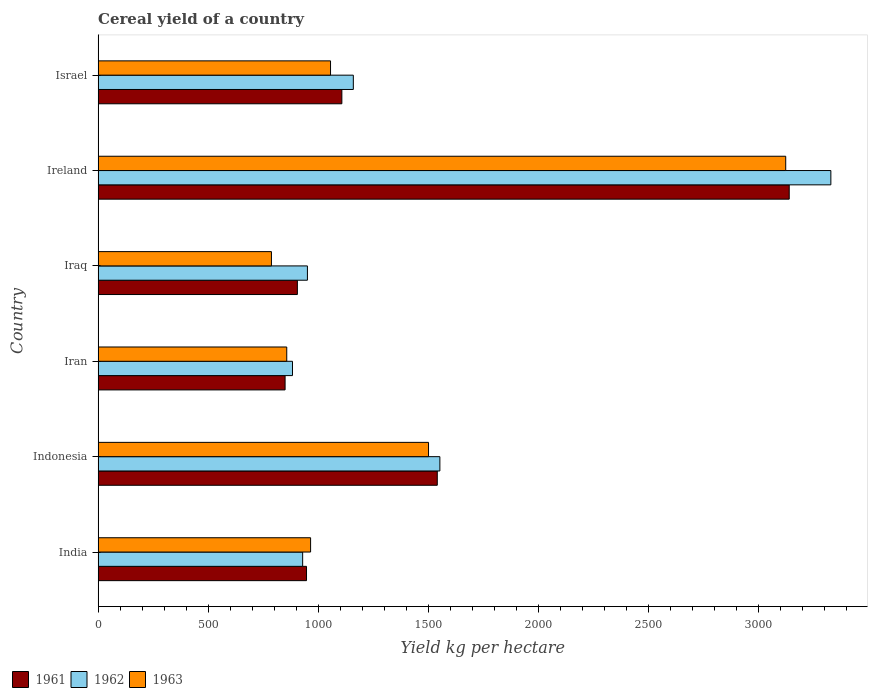How many different coloured bars are there?
Offer a terse response. 3. Are the number of bars on each tick of the Y-axis equal?
Your answer should be very brief. Yes. How many bars are there on the 3rd tick from the top?
Make the answer very short. 3. How many bars are there on the 5th tick from the bottom?
Your response must be concise. 3. What is the total cereal yield in 1963 in Israel?
Provide a succinct answer. 1056.48. Across all countries, what is the maximum total cereal yield in 1961?
Offer a terse response. 3141.5. Across all countries, what is the minimum total cereal yield in 1961?
Your answer should be very brief. 849.91. In which country was the total cereal yield in 1962 maximum?
Make the answer very short. Ireland. In which country was the total cereal yield in 1963 minimum?
Offer a terse response. Iraq. What is the total total cereal yield in 1963 in the graph?
Ensure brevity in your answer.  8295.08. What is the difference between the total cereal yield in 1962 in India and that in Iraq?
Provide a short and direct response. -21.69. What is the difference between the total cereal yield in 1962 in Israel and the total cereal yield in 1961 in Iraq?
Provide a short and direct response. 254.32. What is the average total cereal yield in 1962 per country?
Provide a short and direct response. 1468.19. What is the difference between the total cereal yield in 1963 and total cereal yield in 1961 in Iran?
Offer a terse response. 7.53. In how many countries, is the total cereal yield in 1963 greater than 1500 kg per hectare?
Your answer should be compact. 2. What is the ratio of the total cereal yield in 1962 in Indonesia to that in Ireland?
Your response must be concise. 0.47. Is the difference between the total cereal yield in 1963 in Indonesia and Iran greater than the difference between the total cereal yield in 1961 in Indonesia and Iran?
Give a very brief answer. No. What is the difference between the highest and the second highest total cereal yield in 1961?
Give a very brief answer. 1599.8. What is the difference between the highest and the lowest total cereal yield in 1963?
Your answer should be compact. 2337.75. In how many countries, is the total cereal yield in 1962 greater than the average total cereal yield in 1962 taken over all countries?
Offer a terse response. 2. What does the 3rd bar from the top in Ireland represents?
Your response must be concise. 1961. Is it the case that in every country, the sum of the total cereal yield in 1963 and total cereal yield in 1962 is greater than the total cereal yield in 1961?
Provide a short and direct response. Yes. How many bars are there?
Provide a short and direct response. 18. How many countries are there in the graph?
Make the answer very short. 6. Does the graph contain any zero values?
Make the answer very short. No. What is the title of the graph?
Give a very brief answer. Cereal yield of a country. What is the label or title of the X-axis?
Provide a short and direct response. Yield kg per hectare. What is the label or title of the Y-axis?
Your answer should be very brief. Country. What is the Yield kg per hectare of 1961 in India?
Offer a very short reply. 947.28. What is the Yield kg per hectare of 1962 in India?
Your answer should be very brief. 929.74. What is the Yield kg per hectare in 1963 in India?
Your answer should be compact. 965.82. What is the Yield kg per hectare in 1961 in Indonesia?
Your answer should be compact. 1541.7. What is the Yield kg per hectare in 1962 in Indonesia?
Ensure brevity in your answer.  1553.54. What is the Yield kg per hectare in 1963 in Indonesia?
Provide a succinct answer. 1501.92. What is the Yield kg per hectare in 1961 in Iran?
Keep it short and to the point. 849.91. What is the Yield kg per hectare in 1962 in Iran?
Your answer should be very brief. 883.55. What is the Yield kg per hectare in 1963 in Iran?
Make the answer very short. 857.44. What is the Yield kg per hectare in 1961 in Iraq?
Ensure brevity in your answer.  905.79. What is the Yield kg per hectare of 1962 in Iraq?
Provide a succinct answer. 951.42. What is the Yield kg per hectare in 1963 in Iraq?
Offer a terse response. 787.83. What is the Yield kg per hectare of 1961 in Ireland?
Provide a short and direct response. 3141.5. What is the Yield kg per hectare in 1962 in Ireland?
Offer a terse response. 3330.77. What is the Yield kg per hectare of 1963 in Ireland?
Your answer should be compact. 3125.58. What is the Yield kg per hectare of 1961 in Israel?
Ensure brevity in your answer.  1107.99. What is the Yield kg per hectare of 1962 in Israel?
Offer a very short reply. 1160.11. What is the Yield kg per hectare of 1963 in Israel?
Your answer should be compact. 1056.48. Across all countries, what is the maximum Yield kg per hectare of 1961?
Offer a very short reply. 3141.5. Across all countries, what is the maximum Yield kg per hectare of 1962?
Provide a short and direct response. 3330.77. Across all countries, what is the maximum Yield kg per hectare of 1963?
Make the answer very short. 3125.58. Across all countries, what is the minimum Yield kg per hectare in 1961?
Keep it short and to the point. 849.91. Across all countries, what is the minimum Yield kg per hectare of 1962?
Offer a terse response. 883.55. Across all countries, what is the minimum Yield kg per hectare in 1963?
Your answer should be very brief. 787.83. What is the total Yield kg per hectare in 1961 in the graph?
Your answer should be very brief. 8494.17. What is the total Yield kg per hectare in 1962 in the graph?
Your response must be concise. 8809.13. What is the total Yield kg per hectare in 1963 in the graph?
Your answer should be very brief. 8295.08. What is the difference between the Yield kg per hectare in 1961 in India and that in Indonesia?
Offer a terse response. -594.42. What is the difference between the Yield kg per hectare in 1962 in India and that in Indonesia?
Ensure brevity in your answer.  -623.8. What is the difference between the Yield kg per hectare of 1963 in India and that in Indonesia?
Make the answer very short. -536.09. What is the difference between the Yield kg per hectare of 1961 in India and that in Iran?
Make the answer very short. 97.37. What is the difference between the Yield kg per hectare in 1962 in India and that in Iran?
Your answer should be very brief. 46.18. What is the difference between the Yield kg per hectare of 1963 in India and that in Iran?
Make the answer very short. 108.38. What is the difference between the Yield kg per hectare in 1961 in India and that in Iraq?
Ensure brevity in your answer.  41.5. What is the difference between the Yield kg per hectare in 1962 in India and that in Iraq?
Your response must be concise. -21.69. What is the difference between the Yield kg per hectare in 1963 in India and that in Iraq?
Provide a short and direct response. 177.99. What is the difference between the Yield kg per hectare in 1961 in India and that in Ireland?
Provide a short and direct response. -2194.22. What is the difference between the Yield kg per hectare of 1962 in India and that in Ireland?
Make the answer very short. -2401.03. What is the difference between the Yield kg per hectare in 1963 in India and that in Ireland?
Ensure brevity in your answer.  -2159.76. What is the difference between the Yield kg per hectare in 1961 in India and that in Israel?
Provide a short and direct response. -160.71. What is the difference between the Yield kg per hectare of 1962 in India and that in Israel?
Give a very brief answer. -230.37. What is the difference between the Yield kg per hectare of 1963 in India and that in Israel?
Offer a terse response. -90.66. What is the difference between the Yield kg per hectare in 1961 in Indonesia and that in Iran?
Give a very brief answer. 691.78. What is the difference between the Yield kg per hectare of 1962 in Indonesia and that in Iran?
Ensure brevity in your answer.  669.99. What is the difference between the Yield kg per hectare of 1963 in Indonesia and that in Iran?
Your response must be concise. 644.48. What is the difference between the Yield kg per hectare of 1961 in Indonesia and that in Iraq?
Provide a succinct answer. 635.91. What is the difference between the Yield kg per hectare in 1962 in Indonesia and that in Iraq?
Offer a terse response. 602.11. What is the difference between the Yield kg per hectare of 1963 in Indonesia and that in Iraq?
Offer a terse response. 714.09. What is the difference between the Yield kg per hectare in 1961 in Indonesia and that in Ireland?
Your answer should be very brief. -1599.8. What is the difference between the Yield kg per hectare of 1962 in Indonesia and that in Ireland?
Your response must be concise. -1777.23. What is the difference between the Yield kg per hectare of 1963 in Indonesia and that in Ireland?
Provide a succinct answer. -1623.67. What is the difference between the Yield kg per hectare in 1961 in Indonesia and that in Israel?
Ensure brevity in your answer.  433.71. What is the difference between the Yield kg per hectare of 1962 in Indonesia and that in Israel?
Ensure brevity in your answer.  393.43. What is the difference between the Yield kg per hectare of 1963 in Indonesia and that in Israel?
Provide a short and direct response. 445.43. What is the difference between the Yield kg per hectare of 1961 in Iran and that in Iraq?
Your answer should be compact. -55.87. What is the difference between the Yield kg per hectare of 1962 in Iran and that in Iraq?
Give a very brief answer. -67.87. What is the difference between the Yield kg per hectare of 1963 in Iran and that in Iraq?
Your answer should be compact. 69.61. What is the difference between the Yield kg per hectare of 1961 in Iran and that in Ireland?
Keep it short and to the point. -2291.59. What is the difference between the Yield kg per hectare of 1962 in Iran and that in Ireland?
Provide a short and direct response. -2447.22. What is the difference between the Yield kg per hectare of 1963 in Iran and that in Ireland?
Provide a short and direct response. -2268.14. What is the difference between the Yield kg per hectare of 1961 in Iran and that in Israel?
Ensure brevity in your answer.  -258.07. What is the difference between the Yield kg per hectare of 1962 in Iran and that in Israel?
Provide a short and direct response. -276.55. What is the difference between the Yield kg per hectare in 1963 in Iran and that in Israel?
Your answer should be very brief. -199.04. What is the difference between the Yield kg per hectare of 1961 in Iraq and that in Ireland?
Ensure brevity in your answer.  -2235.71. What is the difference between the Yield kg per hectare in 1962 in Iraq and that in Ireland?
Your answer should be very brief. -2379.35. What is the difference between the Yield kg per hectare in 1963 in Iraq and that in Ireland?
Give a very brief answer. -2337.75. What is the difference between the Yield kg per hectare of 1961 in Iraq and that in Israel?
Your answer should be very brief. -202.2. What is the difference between the Yield kg per hectare of 1962 in Iraq and that in Israel?
Provide a succinct answer. -208.68. What is the difference between the Yield kg per hectare of 1963 in Iraq and that in Israel?
Keep it short and to the point. -268.65. What is the difference between the Yield kg per hectare in 1961 in Ireland and that in Israel?
Provide a short and direct response. 2033.51. What is the difference between the Yield kg per hectare of 1962 in Ireland and that in Israel?
Give a very brief answer. 2170.67. What is the difference between the Yield kg per hectare of 1963 in Ireland and that in Israel?
Give a very brief answer. 2069.1. What is the difference between the Yield kg per hectare of 1961 in India and the Yield kg per hectare of 1962 in Indonesia?
Offer a terse response. -606.25. What is the difference between the Yield kg per hectare in 1961 in India and the Yield kg per hectare in 1963 in Indonesia?
Your answer should be very brief. -554.63. What is the difference between the Yield kg per hectare of 1962 in India and the Yield kg per hectare of 1963 in Indonesia?
Provide a succinct answer. -572.18. What is the difference between the Yield kg per hectare in 1961 in India and the Yield kg per hectare in 1962 in Iran?
Your response must be concise. 63.73. What is the difference between the Yield kg per hectare in 1961 in India and the Yield kg per hectare in 1963 in Iran?
Your answer should be very brief. 89.84. What is the difference between the Yield kg per hectare in 1962 in India and the Yield kg per hectare in 1963 in Iran?
Offer a terse response. 72.3. What is the difference between the Yield kg per hectare in 1961 in India and the Yield kg per hectare in 1962 in Iraq?
Your answer should be very brief. -4.14. What is the difference between the Yield kg per hectare of 1961 in India and the Yield kg per hectare of 1963 in Iraq?
Offer a terse response. 159.45. What is the difference between the Yield kg per hectare of 1962 in India and the Yield kg per hectare of 1963 in Iraq?
Provide a succinct answer. 141.91. What is the difference between the Yield kg per hectare in 1961 in India and the Yield kg per hectare in 1962 in Ireland?
Offer a very short reply. -2383.49. What is the difference between the Yield kg per hectare of 1961 in India and the Yield kg per hectare of 1963 in Ireland?
Provide a short and direct response. -2178.3. What is the difference between the Yield kg per hectare of 1962 in India and the Yield kg per hectare of 1963 in Ireland?
Your answer should be compact. -2195.85. What is the difference between the Yield kg per hectare in 1961 in India and the Yield kg per hectare in 1962 in Israel?
Offer a terse response. -212.82. What is the difference between the Yield kg per hectare of 1961 in India and the Yield kg per hectare of 1963 in Israel?
Your answer should be compact. -109.2. What is the difference between the Yield kg per hectare in 1962 in India and the Yield kg per hectare in 1963 in Israel?
Provide a succinct answer. -126.75. What is the difference between the Yield kg per hectare of 1961 in Indonesia and the Yield kg per hectare of 1962 in Iran?
Ensure brevity in your answer.  658.15. What is the difference between the Yield kg per hectare of 1961 in Indonesia and the Yield kg per hectare of 1963 in Iran?
Offer a very short reply. 684.26. What is the difference between the Yield kg per hectare of 1962 in Indonesia and the Yield kg per hectare of 1963 in Iran?
Give a very brief answer. 696.1. What is the difference between the Yield kg per hectare of 1961 in Indonesia and the Yield kg per hectare of 1962 in Iraq?
Make the answer very short. 590.27. What is the difference between the Yield kg per hectare in 1961 in Indonesia and the Yield kg per hectare in 1963 in Iraq?
Make the answer very short. 753.87. What is the difference between the Yield kg per hectare in 1962 in Indonesia and the Yield kg per hectare in 1963 in Iraq?
Keep it short and to the point. 765.71. What is the difference between the Yield kg per hectare in 1961 in Indonesia and the Yield kg per hectare in 1962 in Ireland?
Offer a terse response. -1789.07. What is the difference between the Yield kg per hectare in 1961 in Indonesia and the Yield kg per hectare in 1963 in Ireland?
Make the answer very short. -1583.88. What is the difference between the Yield kg per hectare in 1962 in Indonesia and the Yield kg per hectare in 1963 in Ireland?
Offer a terse response. -1572.05. What is the difference between the Yield kg per hectare in 1961 in Indonesia and the Yield kg per hectare in 1962 in Israel?
Your answer should be compact. 381.6. What is the difference between the Yield kg per hectare in 1961 in Indonesia and the Yield kg per hectare in 1963 in Israel?
Keep it short and to the point. 485.22. What is the difference between the Yield kg per hectare in 1962 in Indonesia and the Yield kg per hectare in 1963 in Israel?
Provide a succinct answer. 497.06. What is the difference between the Yield kg per hectare in 1961 in Iran and the Yield kg per hectare in 1962 in Iraq?
Provide a short and direct response. -101.51. What is the difference between the Yield kg per hectare of 1961 in Iran and the Yield kg per hectare of 1963 in Iraq?
Provide a succinct answer. 62.09. What is the difference between the Yield kg per hectare in 1962 in Iran and the Yield kg per hectare in 1963 in Iraq?
Provide a succinct answer. 95.72. What is the difference between the Yield kg per hectare of 1961 in Iran and the Yield kg per hectare of 1962 in Ireland?
Keep it short and to the point. -2480.86. What is the difference between the Yield kg per hectare of 1961 in Iran and the Yield kg per hectare of 1963 in Ireland?
Offer a terse response. -2275.67. What is the difference between the Yield kg per hectare in 1962 in Iran and the Yield kg per hectare in 1963 in Ireland?
Ensure brevity in your answer.  -2242.03. What is the difference between the Yield kg per hectare in 1961 in Iran and the Yield kg per hectare in 1962 in Israel?
Your answer should be very brief. -310.19. What is the difference between the Yield kg per hectare of 1961 in Iran and the Yield kg per hectare of 1963 in Israel?
Offer a terse response. -206.57. What is the difference between the Yield kg per hectare of 1962 in Iran and the Yield kg per hectare of 1963 in Israel?
Keep it short and to the point. -172.93. What is the difference between the Yield kg per hectare in 1961 in Iraq and the Yield kg per hectare in 1962 in Ireland?
Offer a terse response. -2424.99. What is the difference between the Yield kg per hectare of 1961 in Iraq and the Yield kg per hectare of 1963 in Ireland?
Give a very brief answer. -2219.8. What is the difference between the Yield kg per hectare in 1962 in Iraq and the Yield kg per hectare in 1963 in Ireland?
Keep it short and to the point. -2174.16. What is the difference between the Yield kg per hectare in 1961 in Iraq and the Yield kg per hectare in 1962 in Israel?
Make the answer very short. -254.32. What is the difference between the Yield kg per hectare of 1961 in Iraq and the Yield kg per hectare of 1963 in Israel?
Provide a short and direct response. -150.7. What is the difference between the Yield kg per hectare of 1962 in Iraq and the Yield kg per hectare of 1963 in Israel?
Make the answer very short. -105.06. What is the difference between the Yield kg per hectare in 1961 in Ireland and the Yield kg per hectare in 1962 in Israel?
Give a very brief answer. 1981.39. What is the difference between the Yield kg per hectare in 1961 in Ireland and the Yield kg per hectare in 1963 in Israel?
Offer a terse response. 2085.02. What is the difference between the Yield kg per hectare in 1962 in Ireland and the Yield kg per hectare in 1963 in Israel?
Provide a succinct answer. 2274.29. What is the average Yield kg per hectare in 1961 per country?
Provide a succinct answer. 1415.7. What is the average Yield kg per hectare of 1962 per country?
Give a very brief answer. 1468.19. What is the average Yield kg per hectare of 1963 per country?
Your response must be concise. 1382.51. What is the difference between the Yield kg per hectare in 1961 and Yield kg per hectare in 1962 in India?
Your answer should be very brief. 17.55. What is the difference between the Yield kg per hectare of 1961 and Yield kg per hectare of 1963 in India?
Keep it short and to the point. -18.54. What is the difference between the Yield kg per hectare of 1962 and Yield kg per hectare of 1963 in India?
Ensure brevity in your answer.  -36.09. What is the difference between the Yield kg per hectare in 1961 and Yield kg per hectare in 1962 in Indonesia?
Make the answer very short. -11.84. What is the difference between the Yield kg per hectare of 1961 and Yield kg per hectare of 1963 in Indonesia?
Offer a terse response. 39.78. What is the difference between the Yield kg per hectare of 1962 and Yield kg per hectare of 1963 in Indonesia?
Give a very brief answer. 51.62. What is the difference between the Yield kg per hectare in 1961 and Yield kg per hectare in 1962 in Iran?
Your answer should be very brief. -33.64. What is the difference between the Yield kg per hectare in 1961 and Yield kg per hectare in 1963 in Iran?
Your answer should be compact. -7.53. What is the difference between the Yield kg per hectare of 1962 and Yield kg per hectare of 1963 in Iran?
Offer a very short reply. 26.11. What is the difference between the Yield kg per hectare of 1961 and Yield kg per hectare of 1962 in Iraq?
Offer a terse response. -45.64. What is the difference between the Yield kg per hectare in 1961 and Yield kg per hectare in 1963 in Iraq?
Give a very brief answer. 117.96. What is the difference between the Yield kg per hectare of 1962 and Yield kg per hectare of 1963 in Iraq?
Make the answer very short. 163.59. What is the difference between the Yield kg per hectare of 1961 and Yield kg per hectare of 1962 in Ireland?
Your response must be concise. -189.27. What is the difference between the Yield kg per hectare of 1961 and Yield kg per hectare of 1963 in Ireland?
Provide a short and direct response. 15.92. What is the difference between the Yield kg per hectare in 1962 and Yield kg per hectare in 1963 in Ireland?
Make the answer very short. 205.19. What is the difference between the Yield kg per hectare of 1961 and Yield kg per hectare of 1962 in Israel?
Keep it short and to the point. -52.12. What is the difference between the Yield kg per hectare of 1961 and Yield kg per hectare of 1963 in Israel?
Keep it short and to the point. 51.51. What is the difference between the Yield kg per hectare in 1962 and Yield kg per hectare in 1963 in Israel?
Offer a very short reply. 103.62. What is the ratio of the Yield kg per hectare in 1961 in India to that in Indonesia?
Ensure brevity in your answer.  0.61. What is the ratio of the Yield kg per hectare of 1962 in India to that in Indonesia?
Your answer should be compact. 0.6. What is the ratio of the Yield kg per hectare in 1963 in India to that in Indonesia?
Your answer should be compact. 0.64. What is the ratio of the Yield kg per hectare in 1961 in India to that in Iran?
Offer a very short reply. 1.11. What is the ratio of the Yield kg per hectare in 1962 in India to that in Iran?
Your response must be concise. 1.05. What is the ratio of the Yield kg per hectare of 1963 in India to that in Iran?
Keep it short and to the point. 1.13. What is the ratio of the Yield kg per hectare in 1961 in India to that in Iraq?
Your answer should be compact. 1.05. What is the ratio of the Yield kg per hectare of 1962 in India to that in Iraq?
Provide a short and direct response. 0.98. What is the ratio of the Yield kg per hectare in 1963 in India to that in Iraq?
Keep it short and to the point. 1.23. What is the ratio of the Yield kg per hectare in 1961 in India to that in Ireland?
Provide a short and direct response. 0.3. What is the ratio of the Yield kg per hectare in 1962 in India to that in Ireland?
Your response must be concise. 0.28. What is the ratio of the Yield kg per hectare in 1963 in India to that in Ireland?
Keep it short and to the point. 0.31. What is the ratio of the Yield kg per hectare in 1961 in India to that in Israel?
Offer a very short reply. 0.85. What is the ratio of the Yield kg per hectare in 1962 in India to that in Israel?
Your response must be concise. 0.8. What is the ratio of the Yield kg per hectare in 1963 in India to that in Israel?
Give a very brief answer. 0.91. What is the ratio of the Yield kg per hectare of 1961 in Indonesia to that in Iran?
Give a very brief answer. 1.81. What is the ratio of the Yield kg per hectare in 1962 in Indonesia to that in Iran?
Offer a very short reply. 1.76. What is the ratio of the Yield kg per hectare in 1963 in Indonesia to that in Iran?
Offer a very short reply. 1.75. What is the ratio of the Yield kg per hectare in 1961 in Indonesia to that in Iraq?
Give a very brief answer. 1.7. What is the ratio of the Yield kg per hectare in 1962 in Indonesia to that in Iraq?
Offer a terse response. 1.63. What is the ratio of the Yield kg per hectare in 1963 in Indonesia to that in Iraq?
Your answer should be very brief. 1.91. What is the ratio of the Yield kg per hectare in 1961 in Indonesia to that in Ireland?
Offer a terse response. 0.49. What is the ratio of the Yield kg per hectare in 1962 in Indonesia to that in Ireland?
Keep it short and to the point. 0.47. What is the ratio of the Yield kg per hectare of 1963 in Indonesia to that in Ireland?
Offer a terse response. 0.48. What is the ratio of the Yield kg per hectare in 1961 in Indonesia to that in Israel?
Provide a short and direct response. 1.39. What is the ratio of the Yield kg per hectare of 1962 in Indonesia to that in Israel?
Keep it short and to the point. 1.34. What is the ratio of the Yield kg per hectare of 1963 in Indonesia to that in Israel?
Your answer should be very brief. 1.42. What is the ratio of the Yield kg per hectare of 1961 in Iran to that in Iraq?
Your response must be concise. 0.94. What is the ratio of the Yield kg per hectare of 1962 in Iran to that in Iraq?
Provide a short and direct response. 0.93. What is the ratio of the Yield kg per hectare in 1963 in Iran to that in Iraq?
Your response must be concise. 1.09. What is the ratio of the Yield kg per hectare of 1961 in Iran to that in Ireland?
Your answer should be compact. 0.27. What is the ratio of the Yield kg per hectare in 1962 in Iran to that in Ireland?
Offer a very short reply. 0.27. What is the ratio of the Yield kg per hectare of 1963 in Iran to that in Ireland?
Ensure brevity in your answer.  0.27. What is the ratio of the Yield kg per hectare of 1961 in Iran to that in Israel?
Ensure brevity in your answer.  0.77. What is the ratio of the Yield kg per hectare of 1962 in Iran to that in Israel?
Your answer should be compact. 0.76. What is the ratio of the Yield kg per hectare of 1963 in Iran to that in Israel?
Provide a short and direct response. 0.81. What is the ratio of the Yield kg per hectare in 1961 in Iraq to that in Ireland?
Provide a succinct answer. 0.29. What is the ratio of the Yield kg per hectare of 1962 in Iraq to that in Ireland?
Your answer should be very brief. 0.29. What is the ratio of the Yield kg per hectare in 1963 in Iraq to that in Ireland?
Your response must be concise. 0.25. What is the ratio of the Yield kg per hectare in 1961 in Iraq to that in Israel?
Make the answer very short. 0.82. What is the ratio of the Yield kg per hectare of 1962 in Iraq to that in Israel?
Give a very brief answer. 0.82. What is the ratio of the Yield kg per hectare in 1963 in Iraq to that in Israel?
Offer a very short reply. 0.75. What is the ratio of the Yield kg per hectare in 1961 in Ireland to that in Israel?
Keep it short and to the point. 2.84. What is the ratio of the Yield kg per hectare of 1962 in Ireland to that in Israel?
Ensure brevity in your answer.  2.87. What is the ratio of the Yield kg per hectare in 1963 in Ireland to that in Israel?
Offer a very short reply. 2.96. What is the difference between the highest and the second highest Yield kg per hectare of 1961?
Offer a very short reply. 1599.8. What is the difference between the highest and the second highest Yield kg per hectare of 1962?
Ensure brevity in your answer.  1777.23. What is the difference between the highest and the second highest Yield kg per hectare of 1963?
Your answer should be compact. 1623.67. What is the difference between the highest and the lowest Yield kg per hectare in 1961?
Offer a very short reply. 2291.59. What is the difference between the highest and the lowest Yield kg per hectare of 1962?
Provide a succinct answer. 2447.22. What is the difference between the highest and the lowest Yield kg per hectare in 1963?
Make the answer very short. 2337.75. 